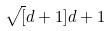<formula> <loc_0><loc_0><loc_500><loc_500>\sqrt { [ } d + 1 ] { d + 1 }</formula> 